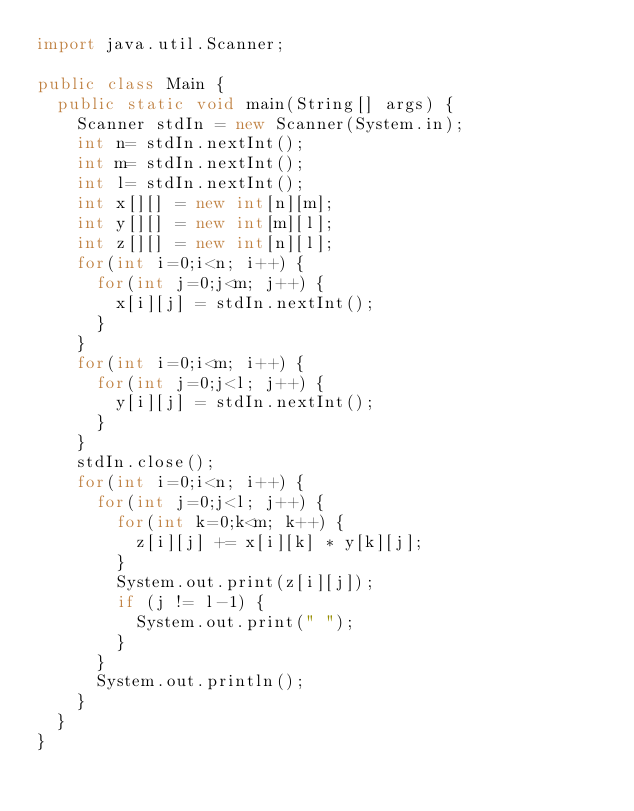Convert code to text. <code><loc_0><loc_0><loc_500><loc_500><_Java_>import java.util.Scanner;

public class Main {
	public static void main(String[] args) {
		Scanner stdIn = new Scanner(System.in);
		int n= stdIn.nextInt();
		int m= stdIn.nextInt();
		int l= stdIn.nextInt();
		int x[][] = new int[n][m];
		int y[][] = new int[m][l];
		int z[][] = new int[n][l];
		for(int i=0;i<n; i++) {
			for(int j=0;j<m; j++) {
				x[i][j] = stdIn.nextInt();
			}
		}
		for(int i=0;i<m; i++) {
			for(int j=0;j<l; j++) {
				y[i][j] = stdIn.nextInt();
			}
		}
		stdIn.close();
		for(int i=0;i<n; i++) {
			for(int j=0;j<l; j++) {
				for(int k=0;k<m; k++) {
					z[i][j] += x[i][k] * y[k][j];
				}
				System.out.print(z[i][j]);
				if (j != l-1) {
					System.out.print(" ");
				}
			}
			System.out.println();
		}
	}
}

</code> 